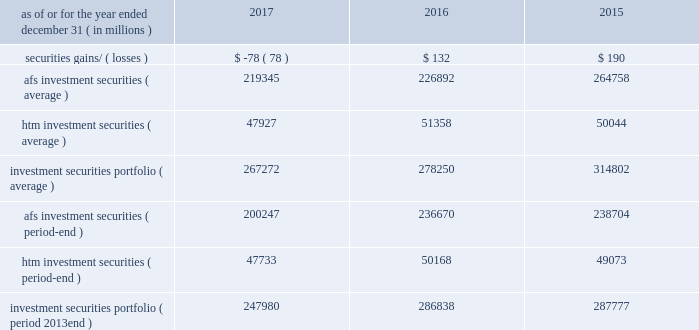Management 2019s discussion and analysis 74 jpmorgan chase & co./2017 annual report treasury and cio overview treasury and cio is predominantly responsible for measuring , monitoring , reporting and managing the firm 2019s liquidity , funding and structural interest rate and foreign exchange risks , as well as executing the firm 2019s capital plan .
The risks managed by treasury and cio arise from the activities undertaken by the firm 2019s four major reportable business segments to serve their respective client bases , which generate both on- and off-balance sheet assets and liabilities .
Treasury and cio seek to achieve the firm 2019s asset-liability management objectives generally by investing in high- quality securities that are managed for the longer-term as part of the firm 2019s investment securities portfolio .
Treasury and cio also use derivatives to meet the firm 2019s asset- liability management objectives .
For further information on derivatives , see note 5 .
The investment securities portfolio primarily consists of agency and nonagency mortgage- backed securities , u.s .
And non-u.s .
Government securities , obligations of u.s .
States and municipalities , other abs and corporate debt securities .
At december 31 , 2017 , the investment securities portfolio was $ 248.0 billion , and the average credit rating of the securities comprising the portfolio was aa+ ( based upon external ratings where available and where not available , based primarily upon internal ratings that correspond to ratings as defined by s&p and moody 2019s ) .
See note 10 for further information on the details of the firm 2019s investment securities portfolio .
For further information on liquidity and funding risk , see liquidity risk management on pages 92 201397 .
For information on interest rate , foreign exchange and other risks , see market risk management on pages 121-128 .
Selected income statement and balance sheet data as of or for the year ended december 31 , ( in millions ) 2017 2016 2015 .
Afs investment securities ( average ) 219345 226892 264758 htm investment securities ( average ) 47927 51358 50044 investment securities portfolio ( average ) 267272 278250 314802 afs investment securities ( period-end ) 200247 236670 238704 htm investment securities ( period-end ) 47733 50168 49073 investment securities portfolio ( period 2013end ) 247980 286838 287777 .
For 2017 , were available for sale securities on average greater than held to maturity securities? 
Rationale: abbreviations
Computations: (219345 > 47927)
Answer: yes. Management 2019s discussion and analysis 74 jpmorgan chase & co./2017 annual report treasury and cio overview treasury and cio is predominantly responsible for measuring , monitoring , reporting and managing the firm 2019s liquidity , funding and structural interest rate and foreign exchange risks , as well as executing the firm 2019s capital plan .
The risks managed by treasury and cio arise from the activities undertaken by the firm 2019s four major reportable business segments to serve their respective client bases , which generate both on- and off-balance sheet assets and liabilities .
Treasury and cio seek to achieve the firm 2019s asset-liability management objectives generally by investing in high- quality securities that are managed for the longer-term as part of the firm 2019s investment securities portfolio .
Treasury and cio also use derivatives to meet the firm 2019s asset- liability management objectives .
For further information on derivatives , see note 5 .
The investment securities portfolio primarily consists of agency and nonagency mortgage- backed securities , u.s .
And non-u.s .
Government securities , obligations of u.s .
States and municipalities , other abs and corporate debt securities .
At december 31 , 2017 , the investment securities portfolio was $ 248.0 billion , and the average credit rating of the securities comprising the portfolio was aa+ ( based upon external ratings where available and where not available , based primarily upon internal ratings that correspond to ratings as defined by s&p and moody 2019s ) .
See note 10 for further information on the details of the firm 2019s investment securities portfolio .
For further information on liquidity and funding risk , see liquidity risk management on pages 92 201397 .
For information on interest rate , foreign exchange and other risks , see market risk management on pages 121-128 .
Selected income statement and balance sheet data as of or for the year ended december 31 , ( in millions ) 2017 2016 2015 .
Afs investment securities ( average ) 219345 226892 264758 htm investment securities ( average ) 47927 51358 50044 investment securities portfolio ( average ) 267272 278250 314802 afs investment securities ( period-end ) 200247 236670 238704 htm investment securities ( period-end ) 47733 50168 49073 investment securities portfolio ( period 2013end ) 247980 286838 287777 .
In 2017 what was the ratio of the afs investment securities at period-end to the average? 
Computations: (200247 / 219345)
Answer: 0.91293. 